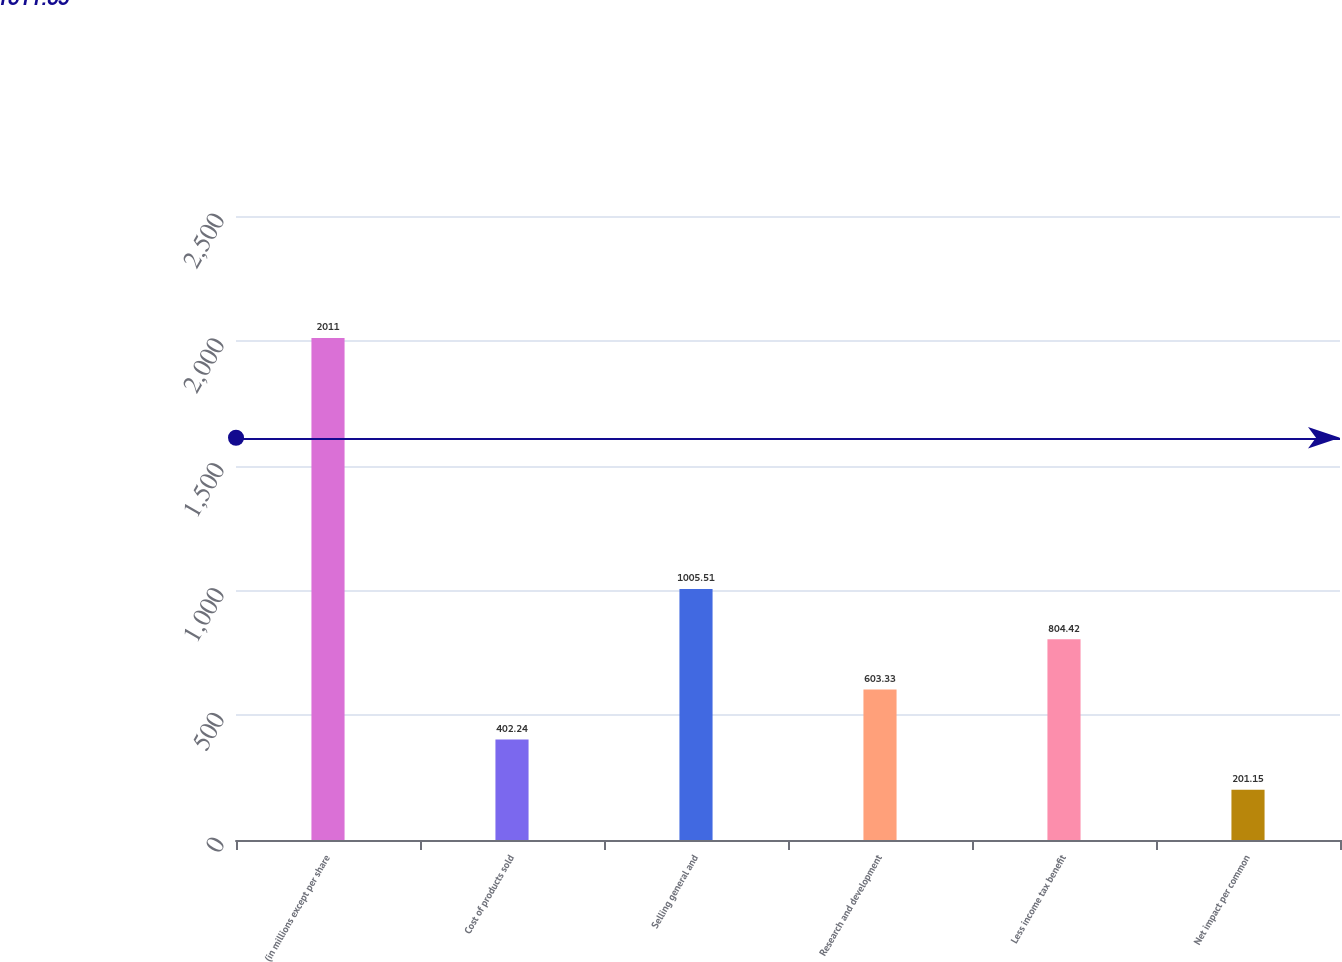<chart> <loc_0><loc_0><loc_500><loc_500><bar_chart><fcel>(in millions except per share<fcel>Cost of products sold<fcel>Selling general and<fcel>Research and development<fcel>Less income tax benefit<fcel>Net impact per common<nl><fcel>2011<fcel>402.24<fcel>1005.51<fcel>603.33<fcel>804.42<fcel>201.15<nl></chart> 